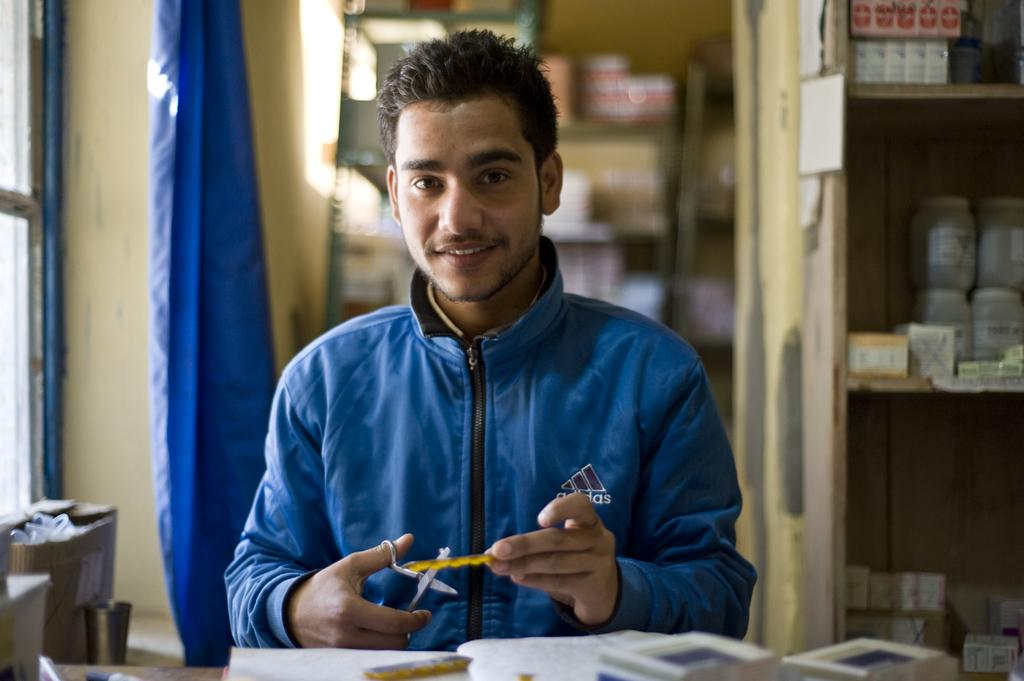What is the main subject of the image? There is a man in the image. Can you describe the man's clothing? The man is wearing a blue jacket. What object is the man holding in the image? The man is holding a scissor. What can be seen on the shelves in the image? There are bottles on a shelf in the image. What objects are on the floor in the image? There is a box and a bucket on the floor in the image. In which direction is the man sleeping in the image? The man is not sleeping in the image; he is standing and holding a scissor. How many knots can be seen tied on the scissor in the image? There are no knots present on the scissor in the image. 